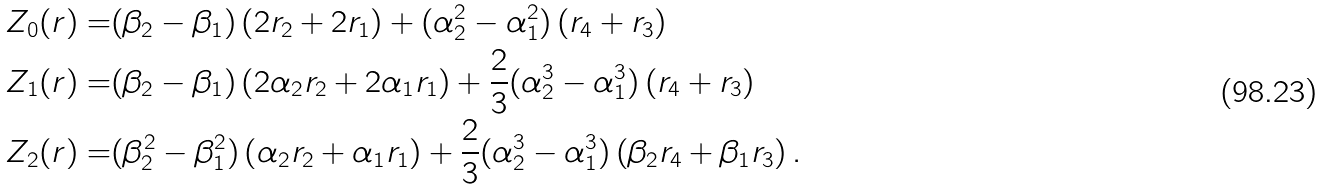Convert formula to latex. <formula><loc_0><loc_0><loc_500><loc_500>Z _ { 0 } ( r ) = & ( \beta _ { 2 } - \beta _ { 1 } ) \left ( 2 r _ { 2 } + 2 r _ { 1 } \right ) + ( \alpha _ { 2 } ^ { 2 } - \alpha _ { 1 } ^ { 2 } ) \left ( r _ { 4 } + r _ { 3 } \right ) \\ Z _ { 1 } ( r ) = & ( \beta _ { 2 } - \beta _ { 1 } ) \left ( 2 \alpha _ { 2 } r _ { 2 } + 2 \alpha _ { 1 } r _ { 1 } \right ) + \frac { 2 } { 3 } ( \alpha _ { 2 } ^ { 3 } - \alpha _ { 1 } ^ { 3 } ) \left ( r _ { 4 } + r _ { 3 } \right ) \\ Z _ { 2 } ( r ) = & ( \beta ^ { 2 } _ { 2 } - \beta ^ { 2 } _ { 1 } ) \left ( \alpha _ { 2 } r _ { 2 } + \alpha _ { 1 } r _ { 1 } \right ) + \frac { 2 } { 3 } ( \alpha ^ { 3 } _ { 2 } - \alpha ^ { 3 } _ { 1 } ) \left ( \beta _ { 2 } r _ { 4 } + \beta _ { 1 } r _ { 3 } \right ) .</formula> 